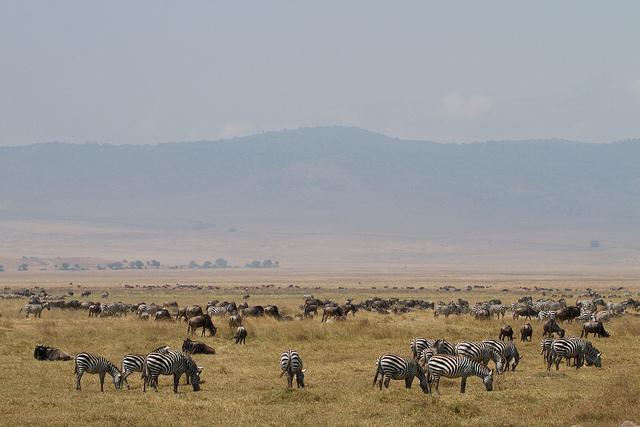How many birds are visible?
Give a very brief answer. 0. 